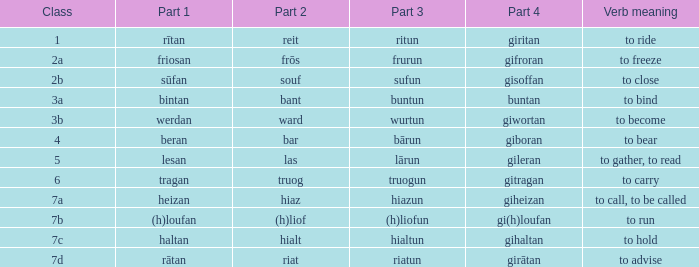What is the verb meaning of the word with part 3 "sufun"? To close. 